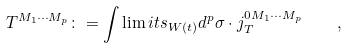<formula> <loc_0><loc_0><loc_500><loc_500>T ^ { M _ { 1 } \cdots M _ { p } } \colon = \int \lim i t s _ { W \left ( t \right ) } d ^ { p } \sigma \cdot j _ { T } ^ { 0 M _ { 1 } \cdots M _ { p } } \quad ,</formula> 